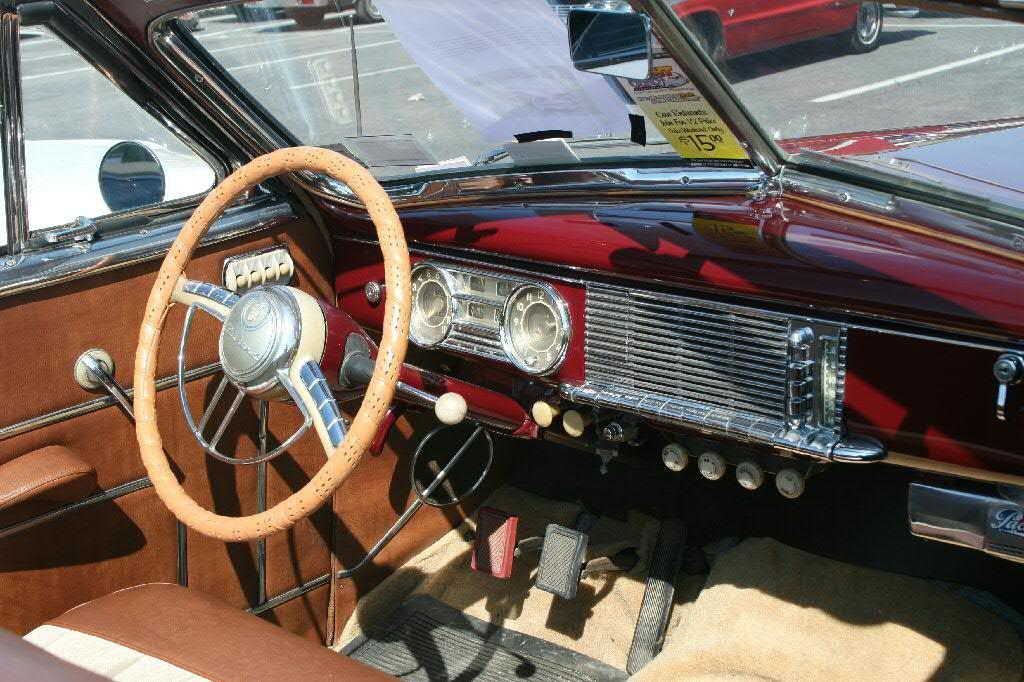What type of setting is depicted in the image? The image shows the interior of a motor vehicle. Can you describe what is visible outside the motor vehicle in the image? There are motor vehicles visible on the road in the background of the image. How do the legs of the motor vehicle behave in the image? Motor vehicles do not have legs, so this question cannot be answered. 